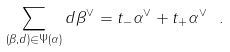<formula> <loc_0><loc_0><loc_500><loc_500>\sum _ { ( \beta , d ) \in \Psi ( \alpha ) } d \beta ^ { \vee } = t _ { - } \alpha ^ { \vee } + t _ { + } \alpha ^ { \vee } \ .</formula> 